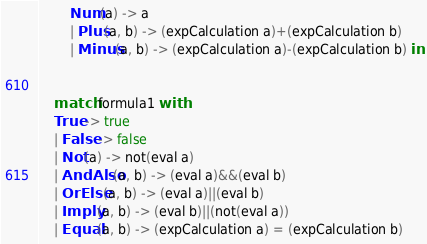Convert code to text. <code><loc_0><loc_0><loc_500><loc_500><_OCaml_>		Num(a) -> a
		| Plus(a, b) -> (expCalculation a)+(expCalculation b)
		| Minus(a, b) -> (expCalculation a)-(expCalculation b) in


	match formula1 with
	True -> true
	| False -> false
	| Not(a) -> not(eval a)
	| AndAlso(a, b) -> (eval a)&&(eval b)
	| OrElse(a, b) -> (eval a)||(eval b)
	| Imply(a, b) -> (eval b)||(not(eval a))
	| Equal(a, b) -> (expCalculation a) = (expCalculation b)</code> 